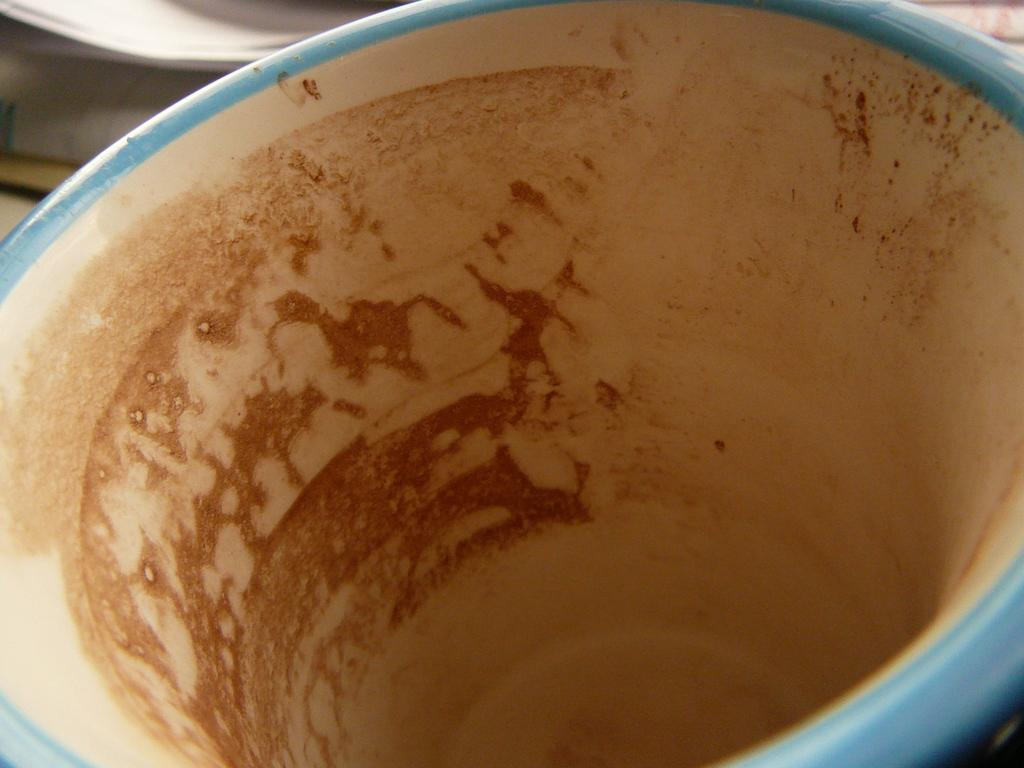What is the main subject of the image? The main subject of the image is a cup. Can you describe the image in more detail? The image is a zoom-in picture of a cup. Where is the receipt located in the image? There is no receipt present in the image; it is a zoom-in picture of a cup. How many people can be seen in the crowd in the image? There is no crowd present in the image; it is a zoom-in picture of a cup. 